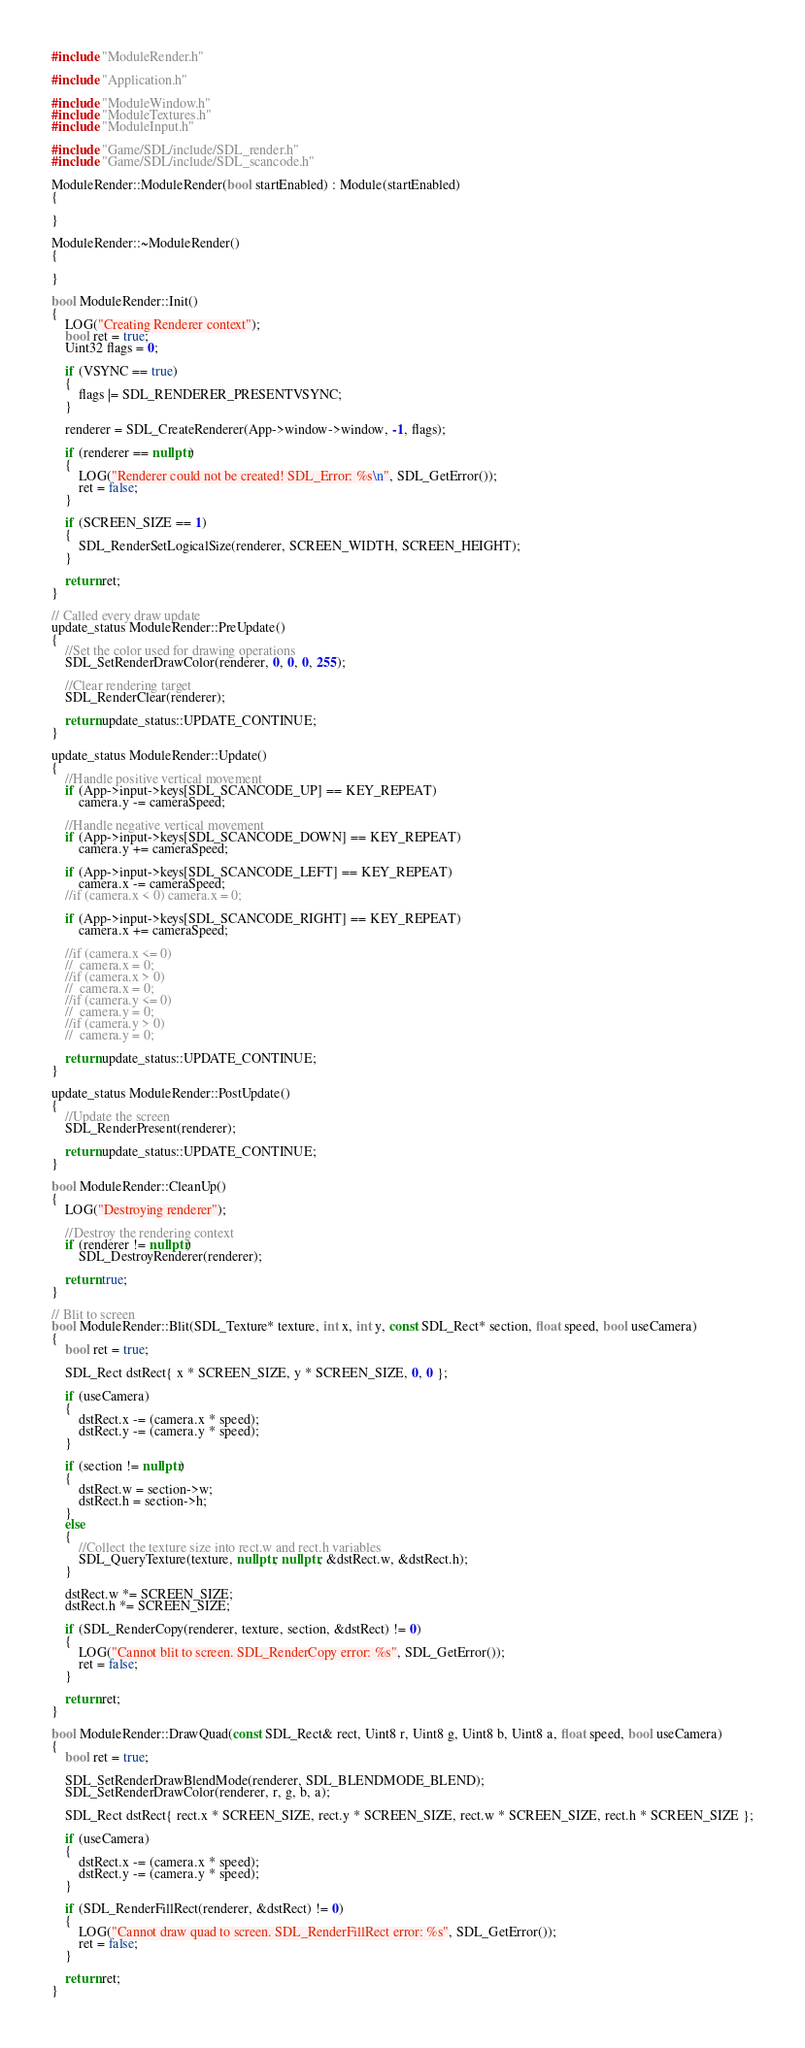Convert code to text. <code><loc_0><loc_0><loc_500><loc_500><_C++_>#include "ModuleRender.h"

#include "Application.h"

#include "ModuleWindow.h"
#include "ModuleTextures.h"
#include "ModuleInput.h"

#include "Game/SDL/include/SDL_render.h"
#include "Game/SDL/include/SDL_scancode.h"

ModuleRender::ModuleRender(bool startEnabled) : Module(startEnabled)
{

}

ModuleRender::~ModuleRender()
{

}

bool ModuleRender::Init()
{
	LOG("Creating Renderer context");
	bool ret = true;	
	Uint32 flags = 0;
	
	if (VSYNC == true)
	{
		flags |= SDL_RENDERER_PRESENTVSYNC;
	}

	renderer = SDL_CreateRenderer(App->window->window, -1, flags);

	if (renderer == nullptr)
	{
		LOG("Renderer could not be created! SDL_Error: %s\n", SDL_GetError());
		ret = false;
	}

	if (SCREEN_SIZE == 1)
	{
		SDL_RenderSetLogicalSize(renderer, SCREEN_WIDTH, SCREEN_HEIGHT);
	}
	
	return ret;
}

// Called every draw update
update_status ModuleRender::PreUpdate()
{
	//Set the color used for drawing operations
	SDL_SetRenderDrawColor(renderer, 0, 0, 0, 255);

	//Clear rendering target
	SDL_RenderClear(renderer);

	return update_status::UPDATE_CONTINUE;
}

update_status ModuleRender::Update()
{
	//Handle positive vertical movement
	if (App->input->keys[SDL_SCANCODE_UP] == KEY_REPEAT)
		camera.y -= cameraSpeed;

	//Handle negative vertical movement
	if (App->input->keys[SDL_SCANCODE_DOWN] == KEY_REPEAT)
		camera.y += cameraSpeed;

	if (App->input->keys[SDL_SCANCODE_LEFT] == KEY_REPEAT)
		camera.x -= cameraSpeed;
	//if (camera.x < 0) camera.x = 0;

	if (App->input->keys[SDL_SCANCODE_RIGHT] == KEY_REPEAT)
		camera.x += cameraSpeed;

	//if (camera.x <= 0)
	//	camera.x = 0;
	//if (camera.x > 0)
	//	camera.x = 0;
	//if (camera.y <= 0)
	//	camera.y = 0;
	//if (camera.y > 0)
	//	camera.y = 0;

	return update_status::UPDATE_CONTINUE;
}

update_status ModuleRender::PostUpdate()
{
	//Update the screen
	SDL_RenderPresent(renderer);

	return update_status::UPDATE_CONTINUE;
}

bool ModuleRender::CleanUp()
{
	LOG("Destroying renderer");

	//Destroy the rendering context
	if (renderer != nullptr)
		SDL_DestroyRenderer(renderer);

	return true;
}

// Blit to screen
bool ModuleRender::Blit(SDL_Texture* texture, int x, int y, const SDL_Rect* section, float speed, bool useCamera)
{
	bool ret = true;

	SDL_Rect dstRect{ x * SCREEN_SIZE, y * SCREEN_SIZE, 0, 0 };

	if (useCamera)
	{
		dstRect.x -= (camera.x * speed);
		dstRect.y -= (camera.y * speed);
	}

	if (section != nullptr)
	{
		dstRect.w = section->w;
		dstRect.h = section->h;
	}
	else
	{
		//Collect the texture size into rect.w and rect.h variables
		SDL_QueryTexture(texture, nullptr, nullptr, &dstRect.w, &dstRect.h);
	}

	dstRect.w *= SCREEN_SIZE;
	dstRect.h *= SCREEN_SIZE;

	if (SDL_RenderCopy(renderer, texture, section, &dstRect) != 0)
	{
		LOG("Cannot blit to screen. SDL_RenderCopy error: %s", SDL_GetError());
		ret = false;
	}

	return ret;
}

bool ModuleRender::DrawQuad(const SDL_Rect& rect, Uint8 r, Uint8 g, Uint8 b, Uint8 a, float speed, bool useCamera)
{
	bool ret = true;

	SDL_SetRenderDrawBlendMode(renderer, SDL_BLENDMODE_BLEND);
	SDL_SetRenderDrawColor(renderer, r, g, b, a);

	SDL_Rect dstRect{ rect.x * SCREEN_SIZE, rect.y * SCREEN_SIZE, rect.w * SCREEN_SIZE, rect.h * SCREEN_SIZE };

	if (useCamera)
	{
		dstRect.x -= (camera.x * speed);
		dstRect.y -= (camera.y * speed);
	}

	if (SDL_RenderFillRect(renderer, &dstRect) != 0)
	{
		LOG("Cannot draw quad to screen. SDL_RenderFillRect error: %s", SDL_GetError());
		ret = false;
	}

	return ret;
}</code> 